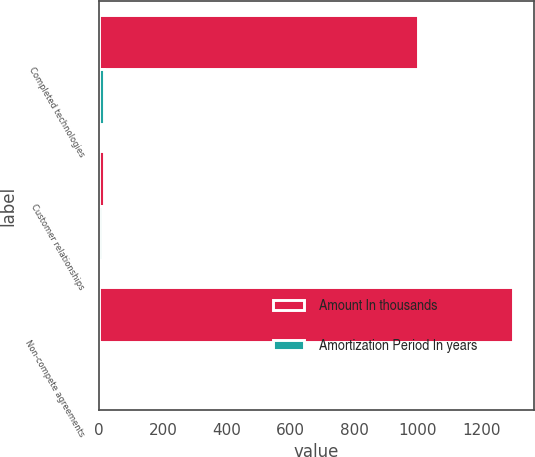Convert chart. <chart><loc_0><loc_0><loc_500><loc_500><stacked_bar_chart><ecel><fcel>Completed technologies<fcel>Customer relationships<fcel>Non-compete agreements<nl><fcel>Amount In thousands<fcel>1000<fcel>14<fcel>1300<nl><fcel>Amortization Period In years<fcel>14<fcel>8<fcel>3<nl></chart> 